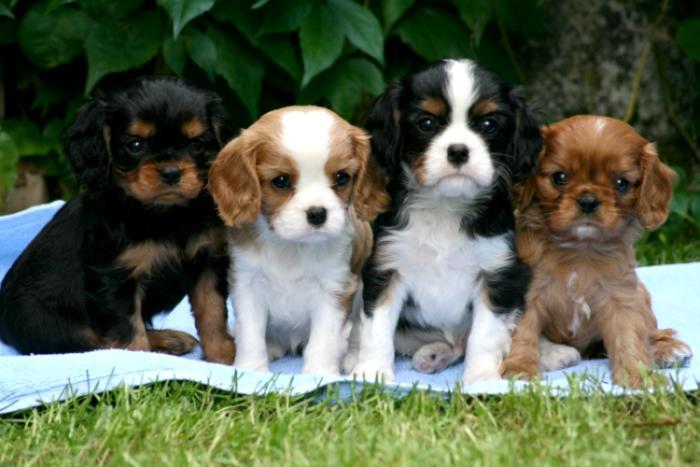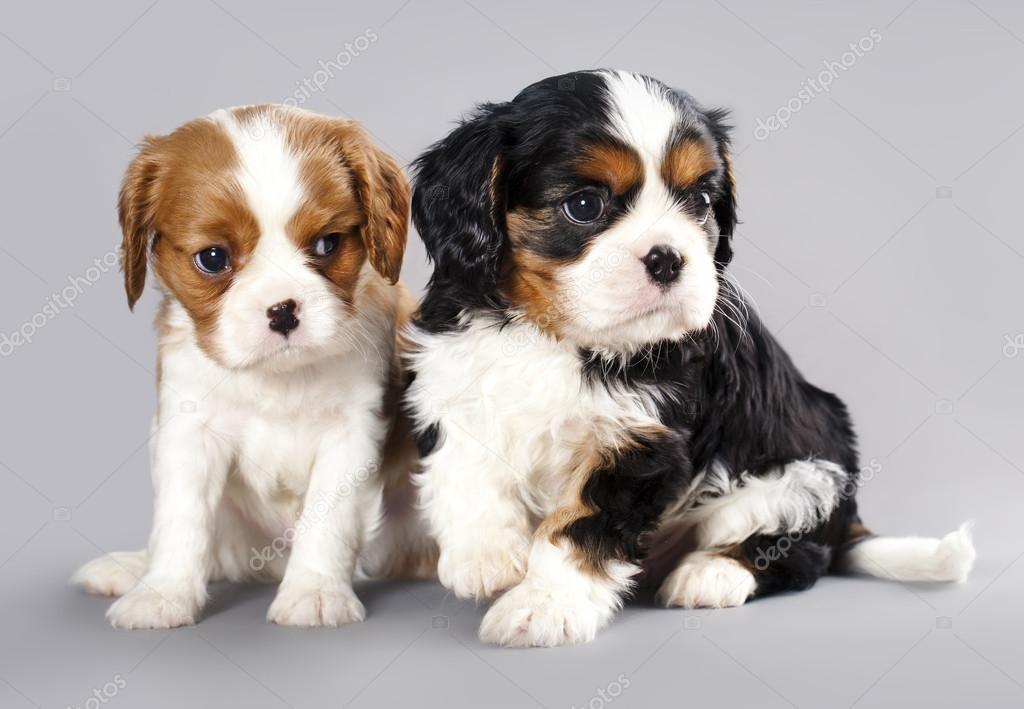The first image is the image on the left, the second image is the image on the right. Evaluate the accuracy of this statement regarding the images: "One image features exactly two puppies, one brown and white, and the other black, brown and white.". Is it true? Answer yes or no. Yes. The first image is the image on the left, the second image is the image on the right. For the images shown, is this caption "There are no more than four cocker spaniels" true? Answer yes or no. No. 